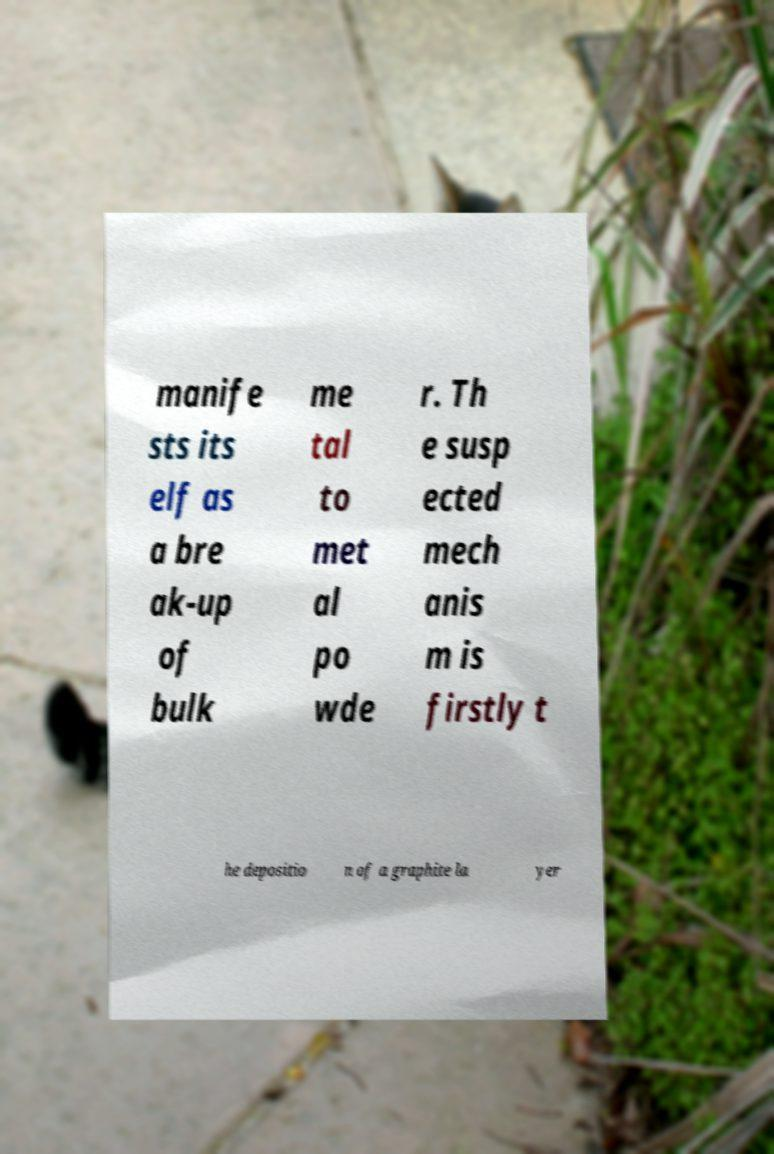What messages or text are displayed in this image? I need them in a readable, typed format. manife sts its elf as a bre ak-up of bulk me tal to met al po wde r. Th e susp ected mech anis m is firstly t he depositio n of a graphite la yer 